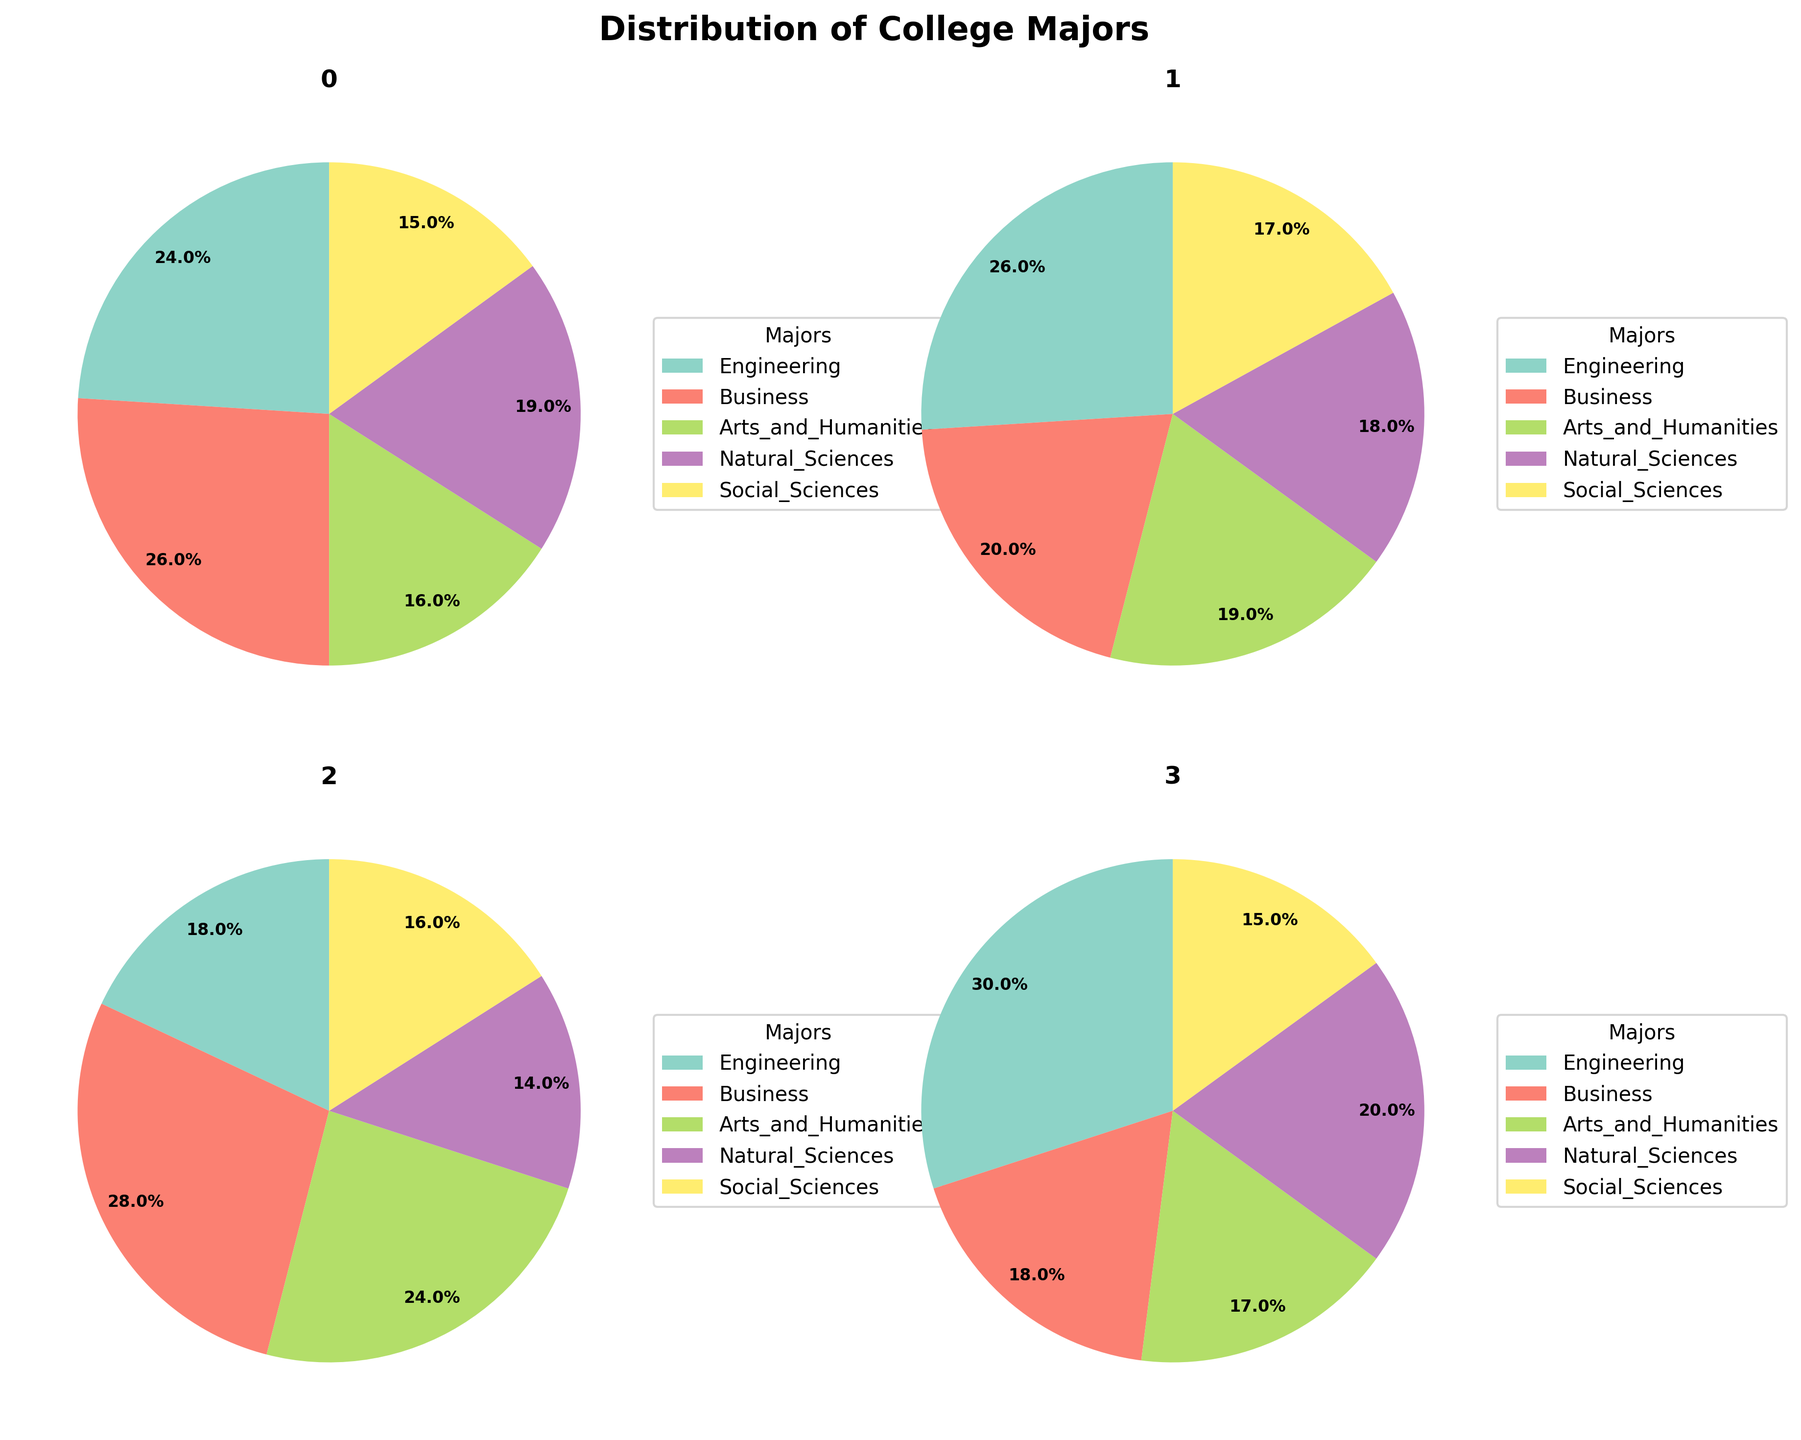Which college has the highest percentage of students in Engineering? First, look at each pie chart's segment labeled Engineering. Identify each percentage value for Ohio State University (24%), University of Texas at Austin (26%), New York University (18%), and University of Michigan (30%). The highest value is 30%, found at the University of Michigan.
Answer: University of Michigan How many colleges have a higher percentage of Arts and Humanities students than Natural Sciences students? Inspect each pie chart and compare the segments of Arts and Humanities to Natural Sciences. Ohio State University has 16% in Arts and Humanities vs. 19% in Natural Sciences (Arts < Natural). University of Texas at Austin has 19% in Arts and Humanities vs. 18% in Natural Sciences (Arts > Natural). New York University has 24% in Arts and Humanities vs. 14% in Natural Sciences (Arts > Natural). University of Michigan has 17% in Arts and Humanities vs. 20% in Natural Sciences (Arts < Natural). Count the instances where Arts and Humanities is greater: UT Austin and NYU.
Answer: 2 Which major is consistently the least chosen among all colleges? For each pie chart, identify the segment with the smallest percentage value. Ohio State University shows Social Sciences at 15%. University of Texas at Austin shows Social Sciences at 17%. New York University shows Natural Sciences at 14%. University of Michigan shows Social Sciences at 15%. The major with the smallest value across the majority of the colleges is Social Sciences.
Answer: Social Sciences How do the percentages of Business students at New York University and Ohio State University compare? Locate the Business segment in New York University's pie chart (28%) and Ohio State University's pie chart (26%). Compare the two values and note that New York University's percentage is higher.
Answer: New York University's percentage is higher What is the ordering of colleges by the percentage of students in Social Sciences from highest to lowest? Look at each pie chart for the Social Sciences segment: Ohio State University (15%), University of Texas at Austin (17%), New York University (16%), University of Michigan (15%). Rank the colleges by these percentages from highest to lowest: University of Texas at Austin (17%), New York University (16%), Ohio State University and University of Michigan tied (15%).
Answer: University of Texas at Austin, New York University, Ohio State University, University of Michigan Which major at Ohio State University has the second-largest student percentage, and what is that percentage? Examine Ohio State University's pie chart and identify the percentages for each major. The largest segment is Business (26%), and the second-largest is Engineering (24%).
Answer: Engineering, 24% What is the combined percentage of Business and Natural Sciences students at the University of Michigan? Locate the segments for Business (18%) and Natural Sciences (20%) in University of Michigan's pie chart. Sum these values: 18% + 20% = 38%.
Answer: 38% Which major has the largest variation in percentage across all colleges? Identify the percentages of each major at every college. Engineering: 24%, 26%, 18%, 30%. Business: 26%, 20%, 28%, 18%. Arts and Humanities: 16%, 19%, 24%, 17%. Natural Sciences: 19%, 18%, 14%, 20%. Social Sciences: 15%, 17%, 16%, 15%. Calculate the range (highest value minus lowest value) for each. The largest range is for Engineering, which is 30% - 18% = 12%.
Answer: Engineering 